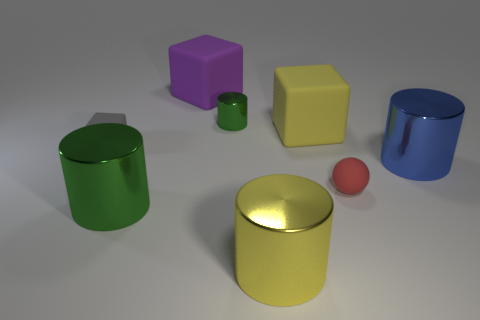Subtract all small cylinders. How many cylinders are left? 3 Subtract all blue blocks. How many green cylinders are left? 2 Subtract all blue cylinders. How many cylinders are left? 3 Subtract 1 cylinders. How many cylinders are left? 3 Add 1 large yellow metallic cubes. How many objects exist? 9 Subtract all purple cylinders. Subtract all brown cubes. How many cylinders are left? 4 Subtract all cubes. How many objects are left? 5 Subtract 1 purple cubes. How many objects are left? 7 Subtract all large yellow things. Subtract all small gray rubber objects. How many objects are left? 5 Add 7 red balls. How many red balls are left? 8 